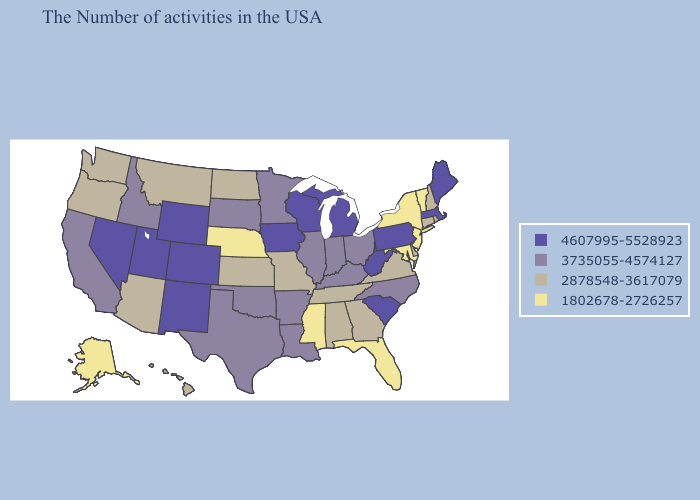Name the states that have a value in the range 1802678-2726257?
Be succinct. Vermont, New York, New Jersey, Maryland, Florida, Mississippi, Nebraska, Alaska. Among the states that border Pennsylvania , does Maryland have the highest value?
Give a very brief answer. No. Name the states that have a value in the range 4607995-5528923?
Quick response, please. Maine, Massachusetts, Pennsylvania, South Carolina, West Virginia, Michigan, Wisconsin, Iowa, Wyoming, Colorado, New Mexico, Utah, Nevada. What is the value of North Dakota?
Give a very brief answer. 2878548-3617079. Does Idaho have the highest value in the West?
Answer briefly. No. What is the value of Massachusetts?
Quick response, please. 4607995-5528923. Name the states that have a value in the range 4607995-5528923?
Write a very short answer. Maine, Massachusetts, Pennsylvania, South Carolina, West Virginia, Michigan, Wisconsin, Iowa, Wyoming, Colorado, New Mexico, Utah, Nevada. Among the states that border Iowa , which have the highest value?
Write a very short answer. Wisconsin. Does the map have missing data?
Be succinct. No. Among the states that border Florida , which have the highest value?
Give a very brief answer. Georgia, Alabama. What is the highest value in states that border Michigan?
Quick response, please. 4607995-5528923. Name the states that have a value in the range 1802678-2726257?
Keep it brief. Vermont, New York, New Jersey, Maryland, Florida, Mississippi, Nebraska, Alaska. What is the highest value in the USA?
Concise answer only. 4607995-5528923. What is the value of California?
Concise answer only. 3735055-4574127. Name the states that have a value in the range 4607995-5528923?
Be succinct. Maine, Massachusetts, Pennsylvania, South Carolina, West Virginia, Michigan, Wisconsin, Iowa, Wyoming, Colorado, New Mexico, Utah, Nevada. 